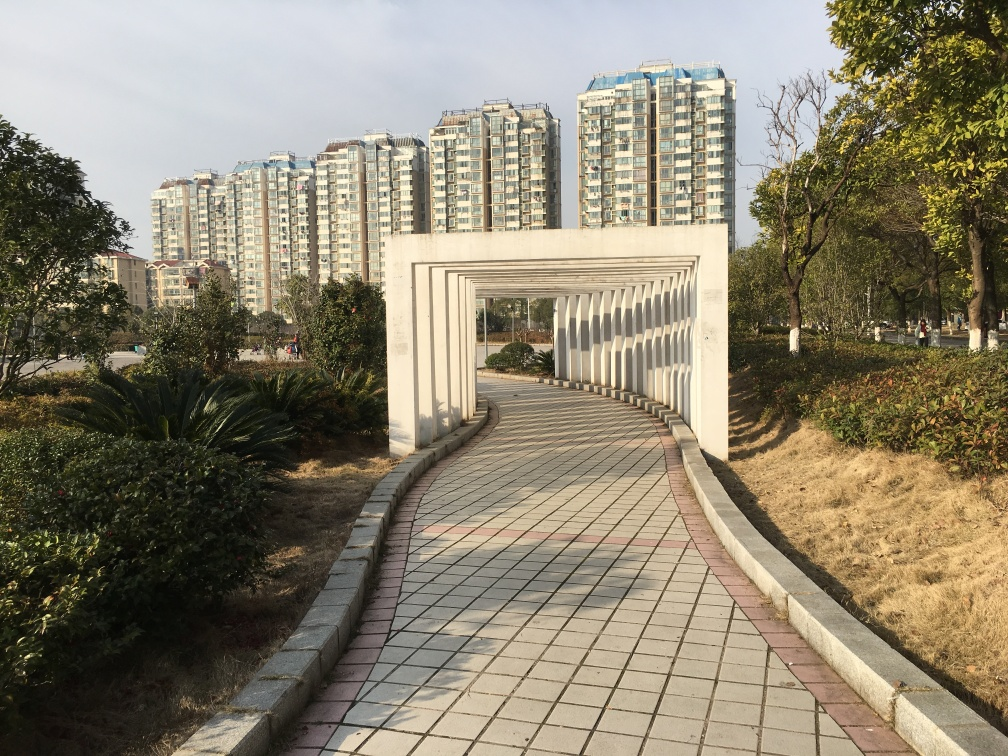Can you describe the architecture style of the buildings in the background? The buildings feature contemporary urban residential architecture, characterized by symmetrical balconies, large glass windows, and a uniform facade that suggests modern construction and living spaces designed for efficiency. 